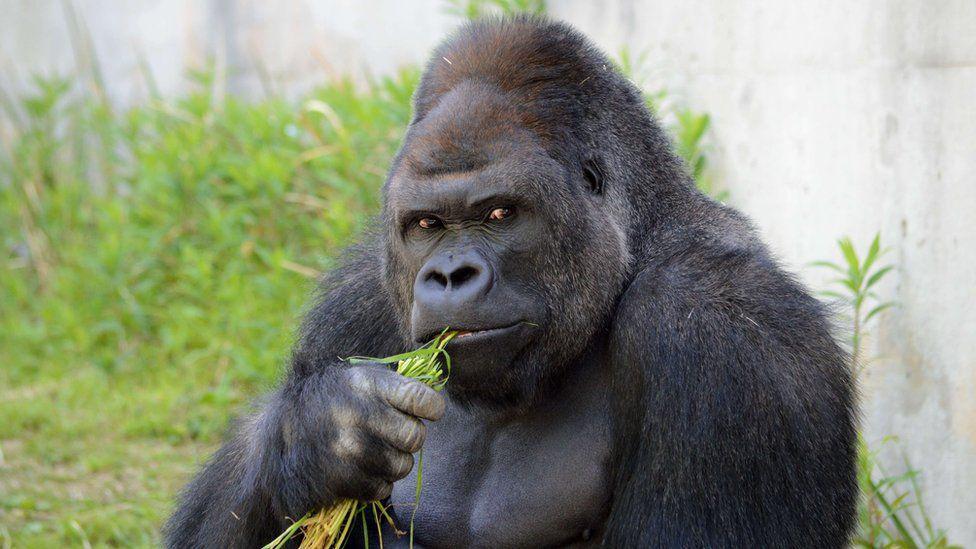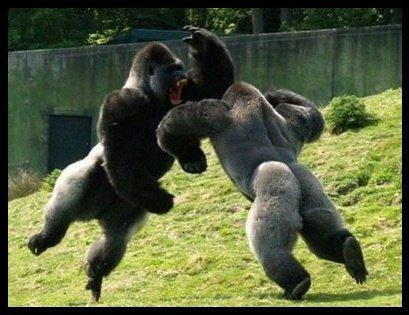The first image is the image on the left, the second image is the image on the right. For the images shown, is this caption "A gorilla is on all fours, but without bared teeth." true? Answer yes or no. No. 